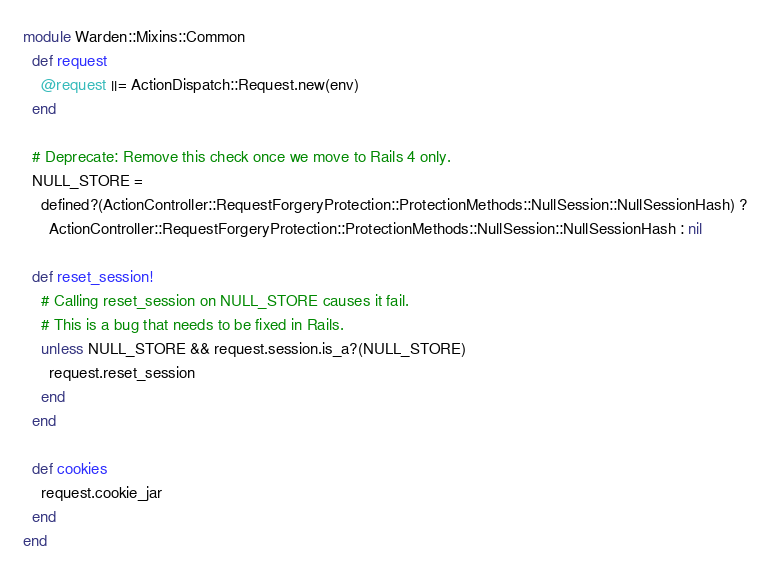<code> <loc_0><loc_0><loc_500><loc_500><_Ruby_>module Warden::Mixins::Common
  def request
    @request ||= ActionDispatch::Request.new(env)
  end

  # Deprecate: Remove this check once we move to Rails 4 only.
  NULL_STORE =
    defined?(ActionController::RequestForgeryProtection::ProtectionMethods::NullSession::NullSessionHash) ?
      ActionController::RequestForgeryProtection::ProtectionMethods::NullSession::NullSessionHash : nil

  def reset_session!
    # Calling reset_session on NULL_STORE causes it fail.
    # This is a bug that needs to be fixed in Rails.
    unless NULL_STORE && request.session.is_a?(NULL_STORE)
      request.reset_session
    end
  end

  def cookies
    request.cookie_jar
  end
end
</code> 